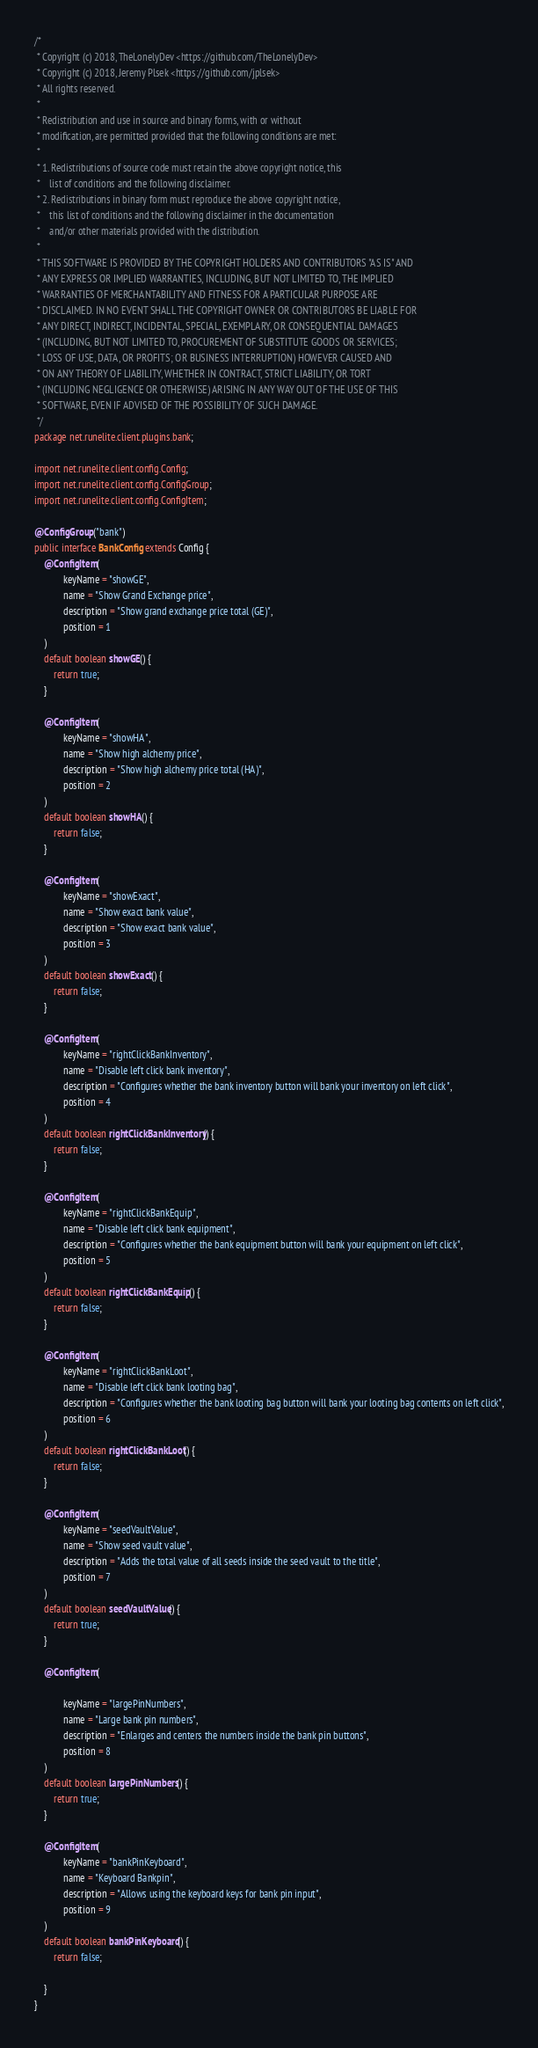<code> <loc_0><loc_0><loc_500><loc_500><_Java_>/*
 * Copyright (c) 2018, TheLonelyDev <https://github.com/TheLonelyDev>
 * Copyright (c) 2018, Jeremy Plsek <https://github.com/jplsek>
 * All rights reserved.
 *
 * Redistribution and use in source and binary forms, with or without
 * modification, are permitted provided that the following conditions are met:
 *
 * 1. Redistributions of source code must retain the above copyright notice, this
 *    list of conditions and the following disclaimer.
 * 2. Redistributions in binary form must reproduce the above copyright notice,
 *    this list of conditions and the following disclaimer in the documentation
 *    and/or other materials provided with the distribution.
 *
 * THIS SOFTWARE IS PROVIDED BY THE COPYRIGHT HOLDERS AND CONTRIBUTORS "AS IS" AND
 * ANY EXPRESS OR IMPLIED WARRANTIES, INCLUDING, BUT NOT LIMITED TO, THE IMPLIED
 * WARRANTIES OF MERCHANTABILITY AND FITNESS FOR A PARTICULAR PURPOSE ARE
 * DISCLAIMED. IN NO EVENT SHALL THE COPYRIGHT OWNER OR CONTRIBUTORS BE LIABLE FOR
 * ANY DIRECT, INDIRECT, INCIDENTAL, SPECIAL, EXEMPLARY, OR CONSEQUENTIAL DAMAGES
 * (INCLUDING, BUT NOT LIMITED TO, PROCUREMENT OF SUBSTITUTE GOODS OR SERVICES;
 * LOSS OF USE, DATA, OR PROFITS; OR BUSINESS INTERRUPTION) HOWEVER CAUSED AND
 * ON ANY THEORY OF LIABILITY, WHETHER IN CONTRACT, STRICT LIABILITY, OR TORT
 * (INCLUDING NEGLIGENCE OR OTHERWISE) ARISING IN ANY WAY OUT OF THE USE OF THIS
 * SOFTWARE, EVEN IF ADVISED OF THE POSSIBILITY OF SUCH DAMAGE.
 */
package net.runelite.client.plugins.bank;

import net.runelite.client.config.Config;
import net.runelite.client.config.ConfigGroup;
import net.runelite.client.config.ConfigItem;

@ConfigGroup("bank")
public interface BankConfig extends Config {
    @ConfigItem(
            keyName = "showGE",
            name = "Show Grand Exchange price",
            description = "Show grand exchange price total (GE)",
            position = 1
    )
    default boolean showGE() {
        return true;
    }

    @ConfigItem(
            keyName = "showHA",
            name = "Show high alchemy price",
            description = "Show high alchemy price total (HA)",
            position = 2
    )
    default boolean showHA() {
        return false;
    }

    @ConfigItem(
            keyName = "showExact",
            name = "Show exact bank value",
            description = "Show exact bank value",
            position = 3
    )
    default boolean showExact() {
        return false;
    }

    @ConfigItem(
            keyName = "rightClickBankInventory",
            name = "Disable left click bank inventory",
            description = "Configures whether the bank inventory button will bank your inventory on left click",
            position = 4
    )
    default boolean rightClickBankInventory() {
        return false;
    }

    @ConfigItem(
            keyName = "rightClickBankEquip",
            name = "Disable left click bank equipment",
            description = "Configures whether the bank equipment button will bank your equipment on left click",
            position = 5
    )
    default boolean rightClickBankEquip() {
        return false;
    }

    @ConfigItem(
            keyName = "rightClickBankLoot",
            name = "Disable left click bank looting bag",
            description = "Configures whether the bank looting bag button will bank your looting bag contents on left click",
            position = 6
    )
    default boolean rightClickBankLoot() {
        return false;
    }

    @ConfigItem(
            keyName = "seedVaultValue",
            name = "Show seed vault value",
            description = "Adds the total value of all seeds inside the seed vault to the title",
            position = 7
    )
    default boolean seedVaultValue() {
        return true;
    }

    @ConfigItem(

            keyName = "largePinNumbers",
            name = "Large bank pin numbers",
            description = "Enlarges and centers the numbers inside the bank pin buttons",
            position = 8
    )
    default boolean largePinNumbers() {
        return true;
    }

    @ConfigItem(
            keyName = "bankPinKeyboard",
            name = "Keyboard Bankpin",
            description = "Allows using the keyboard keys for bank pin input",
            position = 9
    )
    default boolean bankPinKeyboard() {
        return false;

    }
}
</code> 